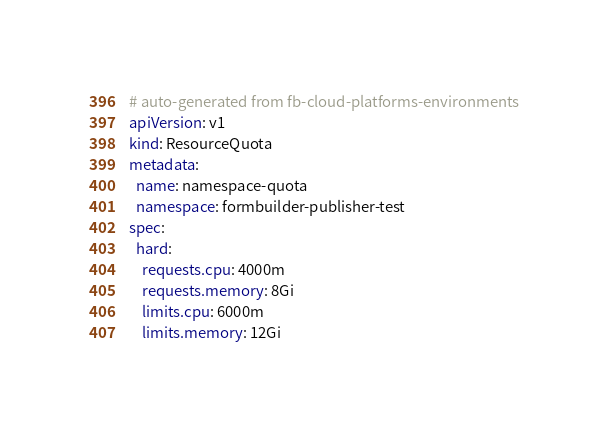Convert code to text. <code><loc_0><loc_0><loc_500><loc_500><_YAML_># auto-generated from fb-cloud-platforms-environments
apiVersion: v1
kind: ResourceQuota
metadata:
  name: namespace-quota
  namespace: formbuilder-publisher-test
spec:
  hard:
    requests.cpu: 4000m
    requests.memory: 8Gi
    limits.cpu: 6000m
    limits.memory: 12Gi
</code> 